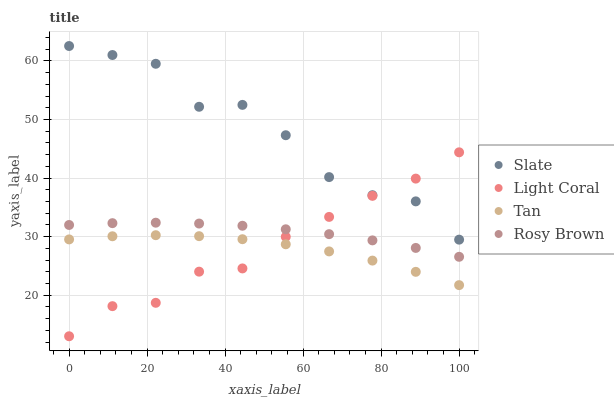Does Tan have the minimum area under the curve?
Answer yes or no. Yes. Does Slate have the maximum area under the curve?
Answer yes or no. Yes. Does Rosy Brown have the minimum area under the curve?
Answer yes or no. No. Does Rosy Brown have the maximum area under the curve?
Answer yes or no. No. Is Rosy Brown the smoothest?
Answer yes or no. Yes. Is Slate the roughest?
Answer yes or no. Yes. Is Slate the smoothest?
Answer yes or no. No. Is Rosy Brown the roughest?
Answer yes or no. No. Does Light Coral have the lowest value?
Answer yes or no. Yes. Does Rosy Brown have the lowest value?
Answer yes or no. No. Does Slate have the highest value?
Answer yes or no. Yes. Does Rosy Brown have the highest value?
Answer yes or no. No. Is Rosy Brown less than Slate?
Answer yes or no. Yes. Is Rosy Brown greater than Tan?
Answer yes or no. Yes. Does Rosy Brown intersect Light Coral?
Answer yes or no. Yes. Is Rosy Brown less than Light Coral?
Answer yes or no. No. Is Rosy Brown greater than Light Coral?
Answer yes or no. No. Does Rosy Brown intersect Slate?
Answer yes or no. No. 